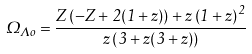Convert formula to latex. <formula><loc_0><loc_0><loc_500><loc_500>\Omega _ { \Lambda o } = { \frac { Z \left ( - Z + 2 ( 1 + z ) \right ) + z \left ( 1 + z \right ) ^ { 2 } } { z \left ( 3 + z ( 3 + z ) \right ) } }</formula> 